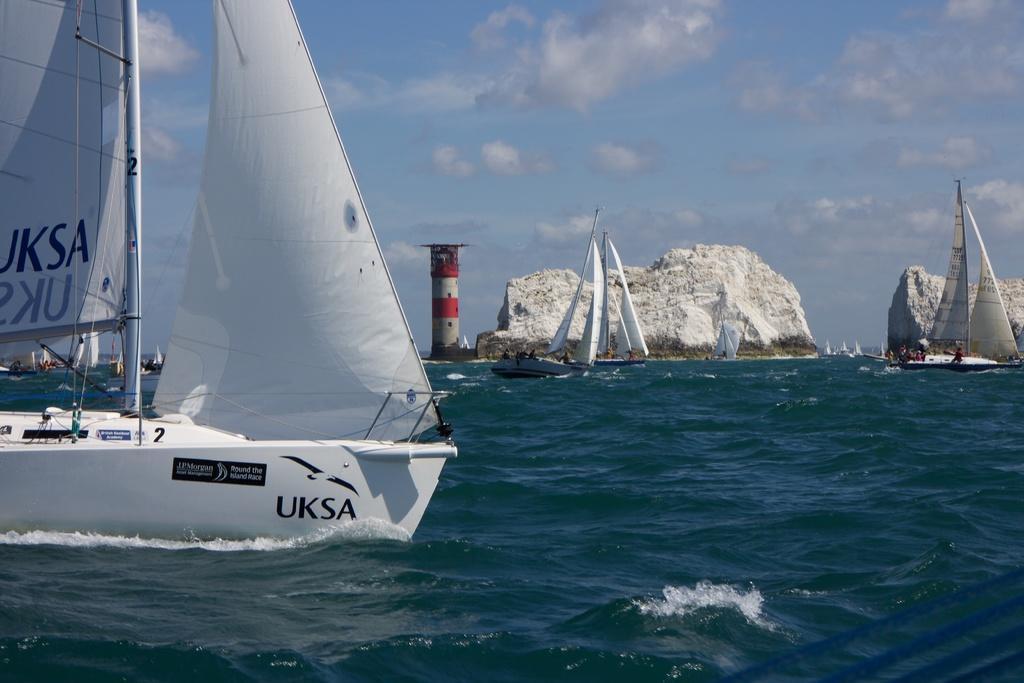Can you describe this image briefly? In this image I can see the water, a boat which is white and black in color on the surface of the water. In the background I can see few boats, few huge rocks and a tower which is red and white in color. I can see the sky. 